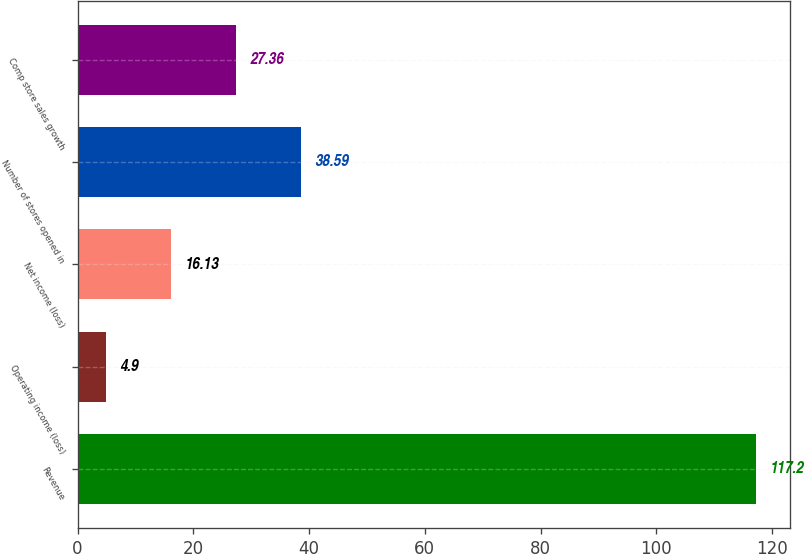<chart> <loc_0><loc_0><loc_500><loc_500><bar_chart><fcel>Revenue<fcel>Operating income (loss)<fcel>Net income (loss)<fcel>Number of stores opened in<fcel>Comp store sales growth<nl><fcel>117.2<fcel>4.9<fcel>16.13<fcel>38.59<fcel>27.36<nl></chart> 